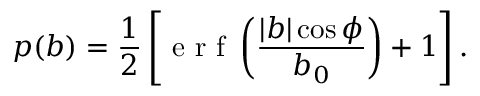Convert formula to latex. <formula><loc_0><loc_0><loc_500><loc_500>p ( b ) = \frac { 1 } { 2 } \left [ e r f \left ( \frac { | b | \cos \phi } { b _ { 0 } } \right ) + 1 \right ] .</formula> 